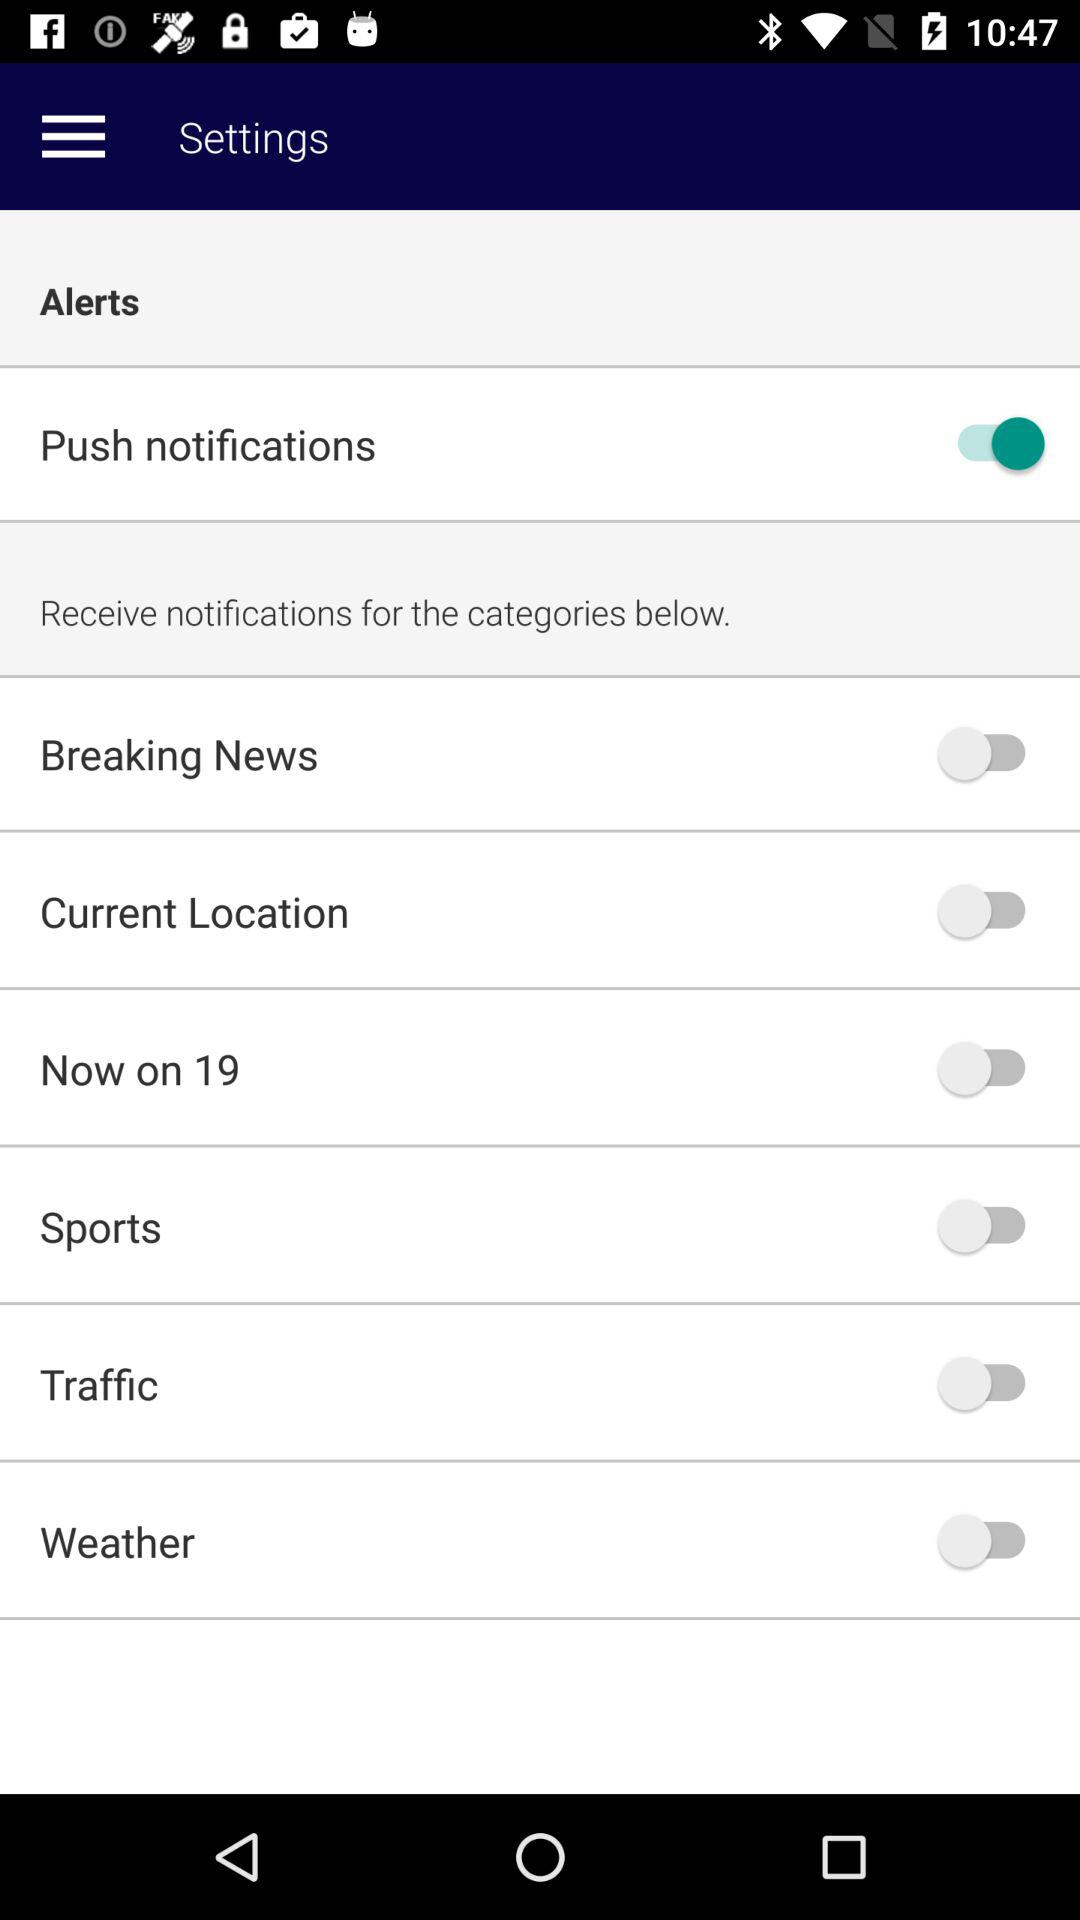How many switches are there in the settings menu?
Answer the question using a single word or phrase. 7 